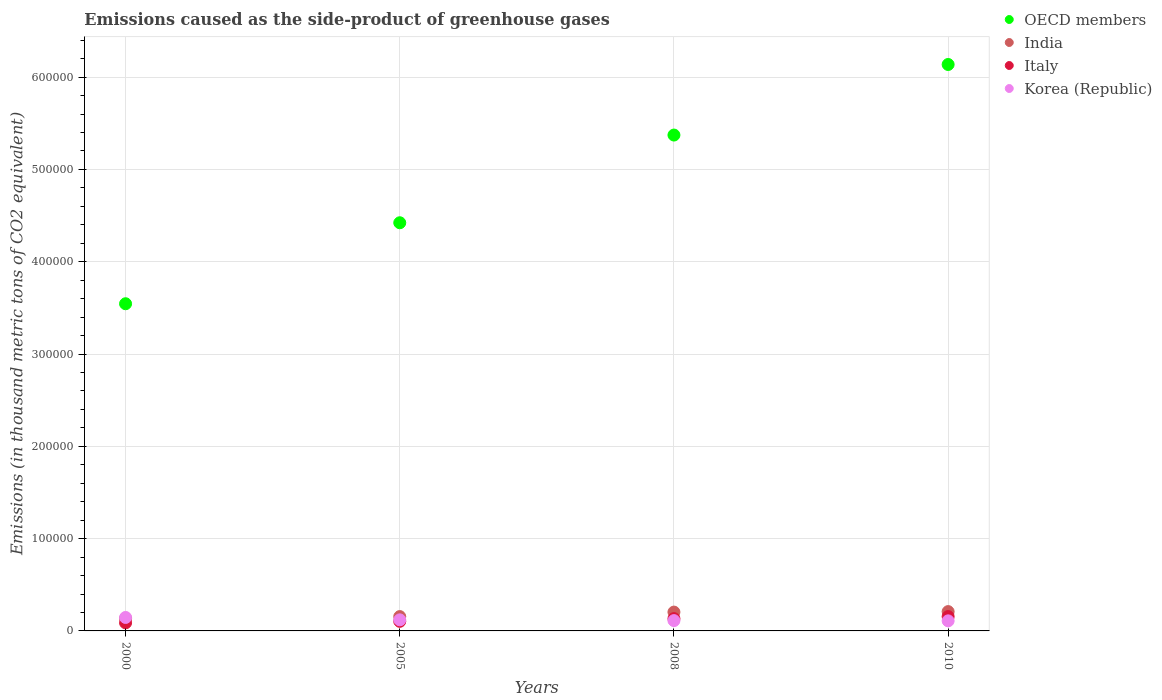What is the emissions caused as the side-product of greenhouse gases in Korea (Republic) in 2010?
Make the answer very short. 1.09e+04. Across all years, what is the maximum emissions caused as the side-product of greenhouse gases in India?
Make the answer very short. 2.09e+04. Across all years, what is the minimum emissions caused as the side-product of greenhouse gases in Korea (Republic)?
Your answer should be very brief. 1.09e+04. In which year was the emissions caused as the side-product of greenhouse gases in OECD members minimum?
Provide a short and direct response. 2000. What is the total emissions caused as the side-product of greenhouse gases in OECD members in the graph?
Provide a short and direct response. 1.95e+06. What is the difference between the emissions caused as the side-product of greenhouse gases in Korea (Republic) in 2008 and that in 2010?
Your answer should be compact. 267.9. What is the difference between the emissions caused as the side-product of greenhouse gases in Italy in 2005 and the emissions caused as the side-product of greenhouse gases in India in 2010?
Your answer should be compact. -1.06e+04. What is the average emissions caused as the side-product of greenhouse gases in Italy per year?
Give a very brief answer. 1.20e+04. In the year 2005, what is the difference between the emissions caused as the side-product of greenhouse gases in Italy and emissions caused as the side-product of greenhouse gases in Korea (Republic)?
Give a very brief answer. -1617.3. What is the ratio of the emissions caused as the side-product of greenhouse gases in Italy in 2000 to that in 2010?
Provide a short and direct response. 0.56. What is the difference between the highest and the second highest emissions caused as the side-product of greenhouse gases in India?
Provide a short and direct response. 530.1. What is the difference between the highest and the lowest emissions caused as the side-product of greenhouse gases in Korea (Republic)?
Your answer should be very brief. 3682.3. In how many years, is the emissions caused as the side-product of greenhouse gases in Korea (Republic) greater than the average emissions caused as the side-product of greenhouse gases in Korea (Republic) taken over all years?
Provide a succinct answer. 1. Is it the case that in every year, the sum of the emissions caused as the side-product of greenhouse gases in Korea (Republic) and emissions caused as the side-product of greenhouse gases in India  is greater than the emissions caused as the side-product of greenhouse gases in Italy?
Provide a succinct answer. Yes. Does the emissions caused as the side-product of greenhouse gases in India monotonically increase over the years?
Give a very brief answer. Yes. Is the emissions caused as the side-product of greenhouse gases in Italy strictly greater than the emissions caused as the side-product of greenhouse gases in OECD members over the years?
Your answer should be very brief. No. Is the emissions caused as the side-product of greenhouse gases in Korea (Republic) strictly less than the emissions caused as the side-product of greenhouse gases in India over the years?
Ensure brevity in your answer.  No. How many dotlines are there?
Your answer should be very brief. 4. Does the graph contain grids?
Make the answer very short. Yes. How many legend labels are there?
Give a very brief answer. 4. What is the title of the graph?
Keep it short and to the point. Emissions caused as the side-product of greenhouse gases. Does "Puerto Rico" appear as one of the legend labels in the graph?
Your answer should be very brief. No. What is the label or title of the Y-axis?
Keep it short and to the point. Emissions (in thousand metric tons of CO2 equivalent). What is the Emissions (in thousand metric tons of CO2 equivalent) of OECD members in 2000?
Give a very brief answer. 3.54e+05. What is the Emissions (in thousand metric tons of CO2 equivalent) in India in 2000?
Offer a terse response. 1.36e+04. What is the Emissions (in thousand metric tons of CO2 equivalent) of Italy in 2000?
Provide a succinct answer. 8752.3. What is the Emissions (in thousand metric tons of CO2 equivalent) of Korea (Republic) in 2000?
Give a very brief answer. 1.46e+04. What is the Emissions (in thousand metric tons of CO2 equivalent) of OECD members in 2005?
Your response must be concise. 4.42e+05. What is the Emissions (in thousand metric tons of CO2 equivalent) in India in 2005?
Offer a very short reply. 1.55e+04. What is the Emissions (in thousand metric tons of CO2 equivalent) of Italy in 2005?
Provide a short and direct response. 1.04e+04. What is the Emissions (in thousand metric tons of CO2 equivalent) of Korea (Republic) in 2005?
Make the answer very short. 1.20e+04. What is the Emissions (in thousand metric tons of CO2 equivalent) of OECD members in 2008?
Provide a succinct answer. 5.37e+05. What is the Emissions (in thousand metric tons of CO2 equivalent) in India in 2008?
Ensure brevity in your answer.  2.04e+04. What is the Emissions (in thousand metric tons of CO2 equivalent) of Italy in 2008?
Keep it short and to the point. 1.33e+04. What is the Emissions (in thousand metric tons of CO2 equivalent) in Korea (Republic) in 2008?
Ensure brevity in your answer.  1.12e+04. What is the Emissions (in thousand metric tons of CO2 equivalent) of OECD members in 2010?
Your answer should be very brief. 6.14e+05. What is the Emissions (in thousand metric tons of CO2 equivalent) in India in 2010?
Keep it short and to the point. 2.09e+04. What is the Emissions (in thousand metric tons of CO2 equivalent) of Italy in 2010?
Give a very brief answer. 1.55e+04. What is the Emissions (in thousand metric tons of CO2 equivalent) of Korea (Republic) in 2010?
Ensure brevity in your answer.  1.09e+04. Across all years, what is the maximum Emissions (in thousand metric tons of CO2 equivalent) of OECD members?
Ensure brevity in your answer.  6.14e+05. Across all years, what is the maximum Emissions (in thousand metric tons of CO2 equivalent) in India?
Make the answer very short. 2.09e+04. Across all years, what is the maximum Emissions (in thousand metric tons of CO2 equivalent) of Italy?
Keep it short and to the point. 1.55e+04. Across all years, what is the maximum Emissions (in thousand metric tons of CO2 equivalent) of Korea (Republic)?
Give a very brief answer. 1.46e+04. Across all years, what is the minimum Emissions (in thousand metric tons of CO2 equivalent) in OECD members?
Your answer should be compact. 3.54e+05. Across all years, what is the minimum Emissions (in thousand metric tons of CO2 equivalent) in India?
Your response must be concise. 1.36e+04. Across all years, what is the minimum Emissions (in thousand metric tons of CO2 equivalent) of Italy?
Ensure brevity in your answer.  8752.3. Across all years, what is the minimum Emissions (in thousand metric tons of CO2 equivalent) in Korea (Republic)?
Make the answer very short. 1.09e+04. What is the total Emissions (in thousand metric tons of CO2 equivalent) in OECD members in the graph?
Your response must be concise. 1.95e+06. What is the total Emissions (in thousand metric tons of CO2 equivalent) in India in the graph?
Your response must be concise. 7.04e+04. What is the total Emissions (in thousand metric tons of CO2 equivalent) of Italy in the graph?
Offer a very short reply. 4.80e+04. What is the total Emissions (in thousand metric tons of CO2 equivalent) in Korea (Republic) in the graph?
Ensure brevity in your answer.  4.87e+04. What is the difference between the Emissions (in thousand metric tons of CO2 equivalent) in OECD members in 2000 and that in 2005?
Make the answer very short. -8.78e+04. What is the difference between the Emissions (in thousand metric tons of CO2 equivalent) in India in 2000 and that in 2005?
Give a very brief answer. -1989. What is the difference between the Emissions (in thousand metric tons of CO2 equivalent) of Italy in 2000 and that in 2005?
Ensure brevity in your answer.  -1633.7. What is the difference between the Emissions (in thousand metric tons of CO2 equivalent) of Korea (Republic) in 2000 and that in 2005?
Your response must be concise. 2584. What is the difference between the Emissions (in thousand metric tons of CO2 equivalent) in OECD members in 2000 and that in 2008?
Offer a terse response. -1.83e+05. What is the difference between the Emissions (in thousand metric tons of CO2 equivalent) of India in 2000 and that in 2008?
Ensure brevity in your answer.  -6856.2. What is the difference between the Emissions (in thousand metric tons of CO2 equivalent) in Italy in 2000 and that in 2008?
Provide a succinct answer. -4573.1. What is the difference between the Emissions (in thousand metric tons of CO2 equivalent) in Korea (Republic) in 2000 and that in 2008?
Offer a very short reply. 3414.4. What is the difference between the Emissions (in thousand metric tons of CO2 equivalent) of OECD members in 2000 and that in 2010?
Keep it short and to the point. -2.59e+05. What is the difference between the Emissions (in thousand metric tons of CO2 equivalent) in India in 2000 and that in 2010?
Your response must be concise. -7386.3. What is the difference between the Emissions (in thousand metric tons of CO2 equivalent) of Italy in 2000 and that in 2010?
Give a very brief answer. -6788.7. What is the difference between the Emissions (in thousand metric tons of CO2 equivalent) in Korea (Republic) in 2000 and that in 2010?
Make the answer very short. 3682.3. What is the difference between the Emissions (in thousand metric tons of CO2 equivalent) in OECD members in 2005 and that in 2008?
Provide a short and direct response. -9.50e+04. What is the difference between the Emissions (in thousand metric tons of CO2 equivalent) of India in 2005 and that in 2008?
Give a very brief answer. -4867.2. What is the difference between the Emissions (in thousand metric tons of CO2 equivalent) of Italy in 2005 and that in 2008?
Make the answer very short. -2939.4. What is the difference between the Emissions (in thousand metric tons of CO2 equivalent) of Korea (Republic) in 2005 and that in 2008?
Keep it short and to the point. 830.4. What is the difference between the Emissions (in thousand metric tons of CO2 equivalent) of OECD members in 2005 and that in 2010?
Ensure brevity in your answer.  -1.71e+05. What is the difference between the Emissions (in thousand metric tons of CO2 equivalent) in India in 2005 and that in 2010?
Your response must be concise. -5397.3. What is the difference between the Emissions (in thousand metric tons of CO2 equivalent) in Italy in 2005 and that in 2010?
Give a very brief answer. -5155. What is the difference between the Emissions (in thousand metric tons of CO2 equivalent) in Korea (Republic) in 2005 and that in 2010?
Keep it short and to the point. 1098.3. What is the difference between the Emissions (in thousand metric tons of CO2 equivalent) of OECD members in 2008 and that in 2010?
Provide a succinct answer. -7.65e+04. What is the difference between the Emissions (in thousand metric tons of CO2 equivalent) of India in 2008 and that in 2010?
Provide a succinct answer. -530.1. What is the difference between the Emissions (in thousand metric tons of CO2 equivalent) of Italy in 2008 and that in 2010?
Provide a short and direct response. -2215.6. What is the difference between the Emissions (in thousand metric tons of CO2 equivalent) of Korea (Republic) in 2008 and that in 2010?
Offer a terse response. 267.9. What is the difference between the Emissions (in thousand metric tons of CO2 equivalent) of OECD members in 2000 and the Emissions (in thousand metric tons of CO2 equivalent) of India in 2005?
Offer a terse response. 3.39e+05. What is the difference between the Emissions (in thousand metric tons of CO2 equivalent) in OECD members in 2000 and the Emissions (in thousand metric tons of CO2 equivalent) in Italy in 2005?
Offer a terse response. 3.44e+05. What is the difference between the Emissions (in thousand metric tons of CO2 equivalent) of OECD members in 2000 and the Emissions (in thousand metric tons of CO2 equivalent) of Korea (Republic) in 2005?
Provide a short and direct response. 3.42e+05. What is the difference between the Emissions (in thousand metric tons of CO2 equivalent) in India in 2000 and the Emissions (in thousand metric tons of CO2 equivalent) in Italy in 2005?
Keep it short and to the point. 3164.7. What is the difference between the Emissions (in thousand metric tons of CO2 equivalent) in India in 2000 and the Emissions (in thousand metric tons of CO2 equivalent) in Korea (Republic) in 2005?
Your response must be concise. 1547.4. What is the difference between the Emissions (in thousand metric tons of CO2 equivalent) in Italy in 2000 and the Emissions (in thousand metric tons of CO2 equivalent) in Korea (Republic) in 2005?
Ensure brevity in your answer.  -3251. What is the difference between the Emissions (in thousand metric tons of CO2 equivalent) of OECD members in 2000 and the Emissions (in thousand metric tons of CO2 equivalent) of India in 2008?
Offer a terse response. 3.34e+05. What is the difference between the Emissions (in thousand metric tons of CO2 equivalent) of OECD members in 2000 and the Emissions (in thousand metric tons of CO2 equivalent) of Italy in 2008?
Make the answer very short. 3.41e+05. What is the difference between the Emissions (in thousand metric tons of CO2 equivalent) in OECD members in 2000 and the Emissions (in thousand metric tons of CO2 equivalent) in Korea (Republic) in 2008?
Ensure brevity in your answer.  3.43e+05. What is the difference between the Emissions (in thousand metric tons of CO2 equivalent) in India in 2000 and the Emissions (in thousand metric tons of CO2 equivalent) in Italy in 2008?
Provide a succinct answer. 225.3. What is the difference between the Emissions (in thousand metric tons of CO2 equivalent) of India in 2000 and the Emissions (in thousand metric tons of CO2 equivalent) of Korea (Republic) in 2008?
Offer a terse response. 2377.8. What is the difference between the Emissions (in thousand metric tons of CO2 equivalent) of Italy in 2000 and the Emissions (in thousand metric tons of CO2 equivalent) of Korea (Republic) in 2008?
Your response must be concise. -2420.6. What is the difference between the Emissions (in thousand metric tons of CO2 equivalent) in OECD members in 2000 and the Emissions (in thousand metric tons of CO2 equivalent) in India in 2010?
Offer a terse response. 3.34e+05. What is the difference between the Emissions (in thousand metric tons of CO2 equivalent) of OECD members in 2000 and the Emissions (in thousand metric tons of CO2 equivalent) of Italy in 2010?
Give a very brief answer. 3.39e+05. What is the difference between the Emissions (in thousand metric tons of CO2 equivalent) in OECD members in 2000 and the Emissions (in thousand metric tons of CO2 equivalent) in Korea (Republic) in 2010?
Your answer should be compact. 3.44e+05. What is the difference between the Emissions (in thousand metric tons of CO2 equivalent) of India in 2000 and the Emissions (in thousand metric tons of CO2 equivalent) of Italy in 2010?
Make the answer very short. -1990.3. What is the difference between the Emissions (in thousand metric tons of CO2 equivalent) of India in 2000 and the Emissions (in thousand metric tons of CO2 equivalent) of Korea (Republic) in 2010?
Provide a short and direct response. 2645.7. What is the difference between the Emissions (in thousand metric tons of CO2 equivalent) in Italy in 2000 and the Emissions (in thousand metric tons of CO2 equivalent) in Korea (Republic) in 2010?
Provide a short and direct response. -2152.7. What is the difference between the Emissions (in thousand metric tons of CO2 equivalent) in OECD members in 2005 and the Emissions (in thousand metric tons of CO2 equivalent) in India in 2008?
Offer a very short reply. 4.22e+05. What is the difference between the Emissions (in thousand metric tons of CO2 equivalent) in OECD members in 2005 and the Emissions (in thousand metric tons of CO2 equivalent) in Italy in 2008?
Your answer should be compact. 4.29e+05. What is the difference between the Emissions (in thousand metric tons of CO2 equivalent) in OECD members in 2005 and the Emissions (in thousand metric tons of CO2 equivalent) in Korea (Republic) in 2008?
Provide a short and direct response. 4.31e+05. What is the difference between the Emissions (in thousand metric tons of CO2 equivalent) in India in 2005 and the Emissions (in thousand metric tons of CO2 equivalent) in Italy in 2008?
Make the answer very short. 2214.3. What is the difference between the Emissions (in thousand metric tons of CO2 equivalent) in India in 2005 and the Emissions (in thousand metric tons of CO2 equivalent) in Korea (Republic) in 2008?
Offer a very short reply. 4366.8. What is the difference between the Emissions (in thousand metric tons of CO2 equivalent) of Italy in 2005 and the Emissions (in thousand metric tons of CO2 equivalent) of Korea (Republic) in 2008?
Provide a short and direct response. -786.9. What is the difference between the Emissions (in thousand metric tons of CO2 equivalent) in OECD members in 2005 and the Emissions (in thousand metric tons of CO2 equivalent) in India in 2010?
Offer a terse response. 4.21e+05. What is the difference between the Emissions (in thousand metric tons of CO2 equivalent) of OECD members in 2005 and the Emissions (in thousand metric tons of CO2 equivalent) of Italy in 2010?
Offer a terse response. 4.27e+05. What is the difference between the Emissions (in thousand metric tons of CO2 equivalent) of OECD members in 2005 and the Emissions (in thousand metric tons of CO2 equivalent) of Korea (Republic) in 2010?
Provide a succinct answer. 4.31e+05. What is the difference between the Emissions (in thousand metric tons of CO2 equivalent) of India in 2005 and the Emissions (in thousand metric tons of CO2 equivalent) of Korea (Republic) in 2010?
Ensure brevity in your answer.  4634.7. What is the difference between the Emissions (in thousand metric tons of CO2 equivalent) of Italy in 2005 and the Emissions (in thousand metric tons of CO2 equivalent) of Korea (Republic) in 2010?
Your answer should be compact. -519. What is the difference between the Emissions (in thousand metric tons of CO2 equivalent) in OECD members in 2008 and the Emissions (in thousand metric tons of CO2 equivalent) in India in 2010?
Make the answer very short. 5.16e+05. What is the difference between the Emissions (in thousand metric tons of CO2 equivalent) in OECD members in 2008 and the Emissions (in thousand metric tons of CO2 equivalent) in Italy in 2010?
Offer a very short reply. 5.22e+05. What is the difference between the Emissions (in thousand metric tons of CO2 equivalent) in OECD members in 2008 and the Emissions (in thousand metric tons of CO2 equivalent) in Korea (Republic) in 2010?
Your answer should be very brief. 5.26e+05. What is the difference between the Emissions (in thousand metric tons of CO2 equivalent) in India in 2008 and the Emissions (in thousand metric tons of CO2 equivalent) in Italy in 2010?
Provide a short and direct response. 4865.9. What is the difference between the Emissions (in thousand metric tons of CO2 equivalent) in India in 2008 and the Emissions (in thousand metric tons of CO2 equivalent) in Korea (Republic) in 2010?
Ensure brevity in your answer.  9501.9. What is the difference between the Emissions (in thousand metric tons of CO2 equivalent) in Italy in 2008 and the Emissions (in thousand metric tons of CO2 equivalent) in Korea (Republic) in 2010?
Your answer should be compact. 2420.4. What is the average Emissions (in thousand metric tons of CO2 equivalent) of OECD members per year?
Your answer should be compact. 4.87e+05. What is the average Emissions (in thousand metric tons of CO2 equivalent) in India per year?
Offer a very short reply. 1.76e+04. What is the average Emissions (in thousand metric tons of CO2 equivalent) of Italy per year?
Make the answer very short. 1.20e+04. What is the average Emissions (in thousand metric tons of CO2 equivalent) in Korea (Republic) per year?
Keep it short and to the point. 1.22e+04. In the year 2000, what is the difference between the Emissions (in thousand metric tons of CO2 equivalent) in OECD members and Emissions (in thousand metric tons of CO2 equivalent) in India?
Offer a terse response. 3.41e+05. In the year 2000, what is the difference between the Emissions (in thousand metric tons of CO2 equivalent) in OECD members and Emissions (in thousand metric tons of CO2 equivalent) in Italy?
Keep it short and to the point. 3.46e+05. In the year 2000, what is the difference between the Emissions (in thousand metric tons of CO2 equivalent) in OECD members and Emissions (in thousand metric tons of CO2 equivalent) in Korea (Republic)?
Keep it short and to the point. 3.40e+05. In the year 2000, what is the difference between the Emissions (in thousand metric tons of CO2 equivalent) in India and Emissions (in thousand metric tons of CO2 equivalent) in Italy?
Your response must be concise. 4798.4. In the year 2000, what is the difference between the Emissions (in thousand metric tons of CO2 equivalent) in India and Emissions (in thousand metric tons of CO2 equivalent) in Korea (Republic)?
Provide a succinct answer. -1036.6. In the year 2000, what is the difference between the Emissions (in thousand metric tons of CO2 equivalent) in Italy and Emissions (in thousand metric tons of CO2 equivalent) in Korea (Republic)?
Provide a short and direct response. -5835. In the year 2005, what is the difference between the Emissions (in thousand metric tons of CO2 equivalent) of OECD members and Emissions (in thousand metric tons of CO2 equivalent) of India?
Your response must be concise. 4.27e+05. In the year 2005, what is the difference between the Emissions (in thousand metric tons of CO2 equivalent) in OECD members and Emissions (in thousand metric tons of CO2 equivalent) in Italy?
Your response must be concise. 4.32e+05. In the year 2005, what is the difference between the Emissions (in thousand metric tons of CO2 equivalent) in OECD members and Emissions (in thousand metric tons of CO2 equivalent) in Korea (Republic)?
Provide a succinct answer. 4.30e+05. In the year 2005, what is the difference between the Emissions (in thousand metric tons of CO2 equivalent) of India and Emissions (in thousand metric tons of CO2 equivalent) of Italy?
Ensure brevity in your answer.  5153.7. In the year 2005, what is the difference between the Emissions (in thousand metric tons of CO2 equivalent) of India and Emissions (in thousand metric tons of CO2 equivalent) of Korea (Republic)?
Make the answer very short. 3536.4. In the year 2005, what is the difference between the Emissions (in thousand metric tons of CO2 equivalent) of Italy and Emissions (in thousand metric tons of CO2 equivalent) of Korea (Republic)?
Offer a terse response. -1617.3. In the year 2008, what is the difference between the Emissions (in thousand metric tons of CO2 equivalent) of OECD members and Emissions (in thousand metric tons of CO2 equivalent) of India?
Your response must be concise. 5.17e+05. In the year 2008, what is the difference between the Emissions (in thousand metric tons of CO2 equivalent) in OECD members and Emissions (in thousand metric tons of CO2 equivalent) in Italy?
Give a very brief answer. 5.24e+05. In the year 2008, what is the difference between the Emissions (in thousand metric tons of CO2 equivalent) in OECD members and Emissions (in thousand metric tons of CO2 equivalent) in Korea (Republic)?
Your response must be concise. 5.26e+05. In the year 2008, what is the difference between the Emissions (in thousand metric tons of CO2 equivalent) in India and Emissions (in thousand metric tons of CO2 equivalent) in Italy?
Provide a succinct answer. 7081.5. In the year 2008, what is the difference between the Emissions (in thousand metric tons of CO2 equivalent) in India and Emissions (in thousand metric tons of CO2 equivalent) in Korea (Republic)?
Provide a short and direct response. 9234. In the year 2008, what is the difference between the Emissions (in thousand metric tons of CO2 equivalent) of Italy and Emissions (in thousand metric tons of CO2 equivalent) of Korea (Republic)?
Provide a succinct answer. 2152.5. In the year 2010, what is the difference between the Emissions (in thousand metric tons of CO2 equivalent) in OECD members and Emissions (in thousand metric tons of CO2 equivalent) in India?
Provide a short and direct response. 5.93e+05. In the year 2010, what is the difference between the Emissions (in thousand metric tons of CO2 equivalent) in OECD members and Emissions (in thousand metric tons of CO2 equivalent) in Italy?
Your answer should be very brief. 5.98e+05. In the year 2010, what is the difference between the Emissions (in thousand metric tons of CO2 equivalent) of OECD members and Emissions (in thousand metric tons of CO2 equivalent) of Korea (Republic)?
Offer a very short reply. 6.03e+05. In the year 2010, what is the difference between the Emissions (in thousand metric tons of CO2 equivalent) in India and Emissions (in thousand metric tons of CO2 equivalent) in Italy?
Provide a short and direct response. 5396. In the year 2010, what is the difference between the Emissions (in thousand metric tons of CO2 equivalent) in India and Emissions (in thousand metric tons of CO2 equivalent) in Korea (Republic)?
Provide a short and direct response. 1.00e+04. In the year 2010, what is the difference between the Emissions (in thousand metric tons of CO2 equivalent) of Italy and Emissions (in thousand metric tons of CO2 equivalent) of Korea (Republic)?
Provide a short and direct response. 4636. What is the ratio of the Emissions (in thousand metric tons of CO2 equivalent) of OECD members in 2000 to that in 2005?
Your response must be concise. 0.8. What is the ratio of the Emissions (in thousand metric tons of CO2 equivalent) of India in 2000 to that in 2005?
Ensure brevity in your answer.  0.87. What is the ratio of the Emissions (in thousand metric tons of CO2 equivalent) of Italy in 2000 to that in 2005?
Your response must be concise. 0.84. What is the ratio of the Emissions (in thousand metric tons of CO2 equivalent) of Korea (Republic) in 2000 to that in 2005?
Offer a terse response. 1.22. What is the ratio of the Emissions (in thousand metric tons of CO2 equivalent) of OECD members in 2000 to that in 2008?
Ensure brevity in your answer.  0.66. What is the ratio of the Emissions (in thousand metric tons of CO2 equivalent) in India in 2000 to that in 2008?
Give a very brief answer. 0.66. What is the ratio of the Emissions (in thousand metric tons of CO2 equivalent) in Italy in 2000 to that in 2008?
Your answer should be compact. 0.66. What is the ratio of the Emissions (in thousand metric tons of CO2 equivalent) in Korea (Republic) in 2000 to that in 2008?
Ensure brevity in your answer.  1.31. What is the ratio of the Emissions (in thousand metric tons of CO2 equivalent) of OECD members in 2000 to that in 2010?
Provide a succinct answer. 0.58. What is the ratio of the Emissions (in thousand metric tons of CO2 equivalent) in India in 2000 to that in 2010?
Offer a very short reply. 0.65. What is the ratio of the Emissions (in thousand metric tons of CO2 equivalent) in Italy in 2000 to that in 2010?
Your answer should be very brief. 0.56. What is the ratio of the Emissions (in thousand metric tons of CO2 equivalent) of Korea (Republic) in 2000 to that in 2010?
Provide a succinct answer. 1.34. What is the ratio of the Emissions (in thousand metric tons of CO2 equivalent) in OECD members in 2005 to that in 2008?
Your answer should be very brief. 0.82. What is the ratio of the Emissions (in thousand metric tons of CO2 equivalent) in India in 2005 to that in 2008?
Your response must be concise. 0.76. What is the ratio of the Emissions (in thousand metric tons of CO2 equivalent) in Italy in 2005 to that in 2008?
Offer a very short reply. 0.78. What is the ratio of the Emissions (in thousand metric tons of CO2 equivalent) in Korea (Republic) in 2005 to that in 2008?
Offer a terse response. 1.07. What is the ratio of the Emissions (in thousand metric tons of CO2 equivalent) of OECD members in 2005 to that in 2010?
Provide a succinct answer. 0.72. What is the ratio of the Emissions (in thousand metric tons of CO2 equivalent) of India in 2005 to that in 2010?
Give a very brief answer. 0.74. What is the ratio of the Emissions (in thousand metric tons of CO2 equivalent) in Italy in 2005 to that in 2010?
Keep it short and to the point. 0.67. What is the ratio of the Emissions (in thousand metric tons of CO2 equivalent) of Korea (Republic) in 2005 to that in 2010?
Provide a succinct answer. 1.1. What is the ratio of the Emissions (in thousand metric tons of CO2 equivalent) in OECD members in 2008 to that in 2010?
Offer a very short reply. 0.88. What is the ratio of the Emissions (in thousand metric tons of CO2 equivalent) of India in 2008 to that in 2010?
Keep it short and to the point. 0.97. What is the ratio of the Emissions (in thousand metric tons of CO2 equivalent) of Italy in 2008 to that in 2010?
Ensure brevity in your answer.  0.86. What is the ratio of the Emissions (in thousand metric tons of CO2 equivalent) of Korea (Republic) in 2008 to that in 2010?
Keep it short and to the point. 1.02. What is the difference between the highest and the second highest Emissions (in thousand metric tons of CO2 equivalent) of OECD members?
Provide a succinct answer. 7.65e+04. What is the difference between the highest and the second highest Emissions (in thousand metric tons of CO2 equivalent) of India?
Provide a succinct answer. 530.1. What is the difference between the highest and the second highest Emissions (in thousand metric tons of CO2 equivalent) in Italy?
Offer a very short reply. 2215.6. What is the difference between the highest and the second highest Emissions (in thousand metric tons of CO2 equivalent) of Korea (Republic)?
Give a very brief answer. 2584. What is the difference between the highest and the lowest Emissions (in thousand metric tons of CO2 equivalent) of OECD members?
Make the answer very short. 2.59e+05. What is the difference between the highest and the lowest Emissions (in thousand metric tons of CO2 equivalent) in India?
Your answer should be compact. 7386.3. What is the difference between the highest and the lowest Emissions (in thousand metric tons of CO2 equivalent) in Italy?
Provide a short and direct response. 6788.7. What is the difference between the highest and the lowest Emissions (in thousand metric tons of CO2 equivalent) in Korea (Republic)?
Make the answer very short. 3682.3. 